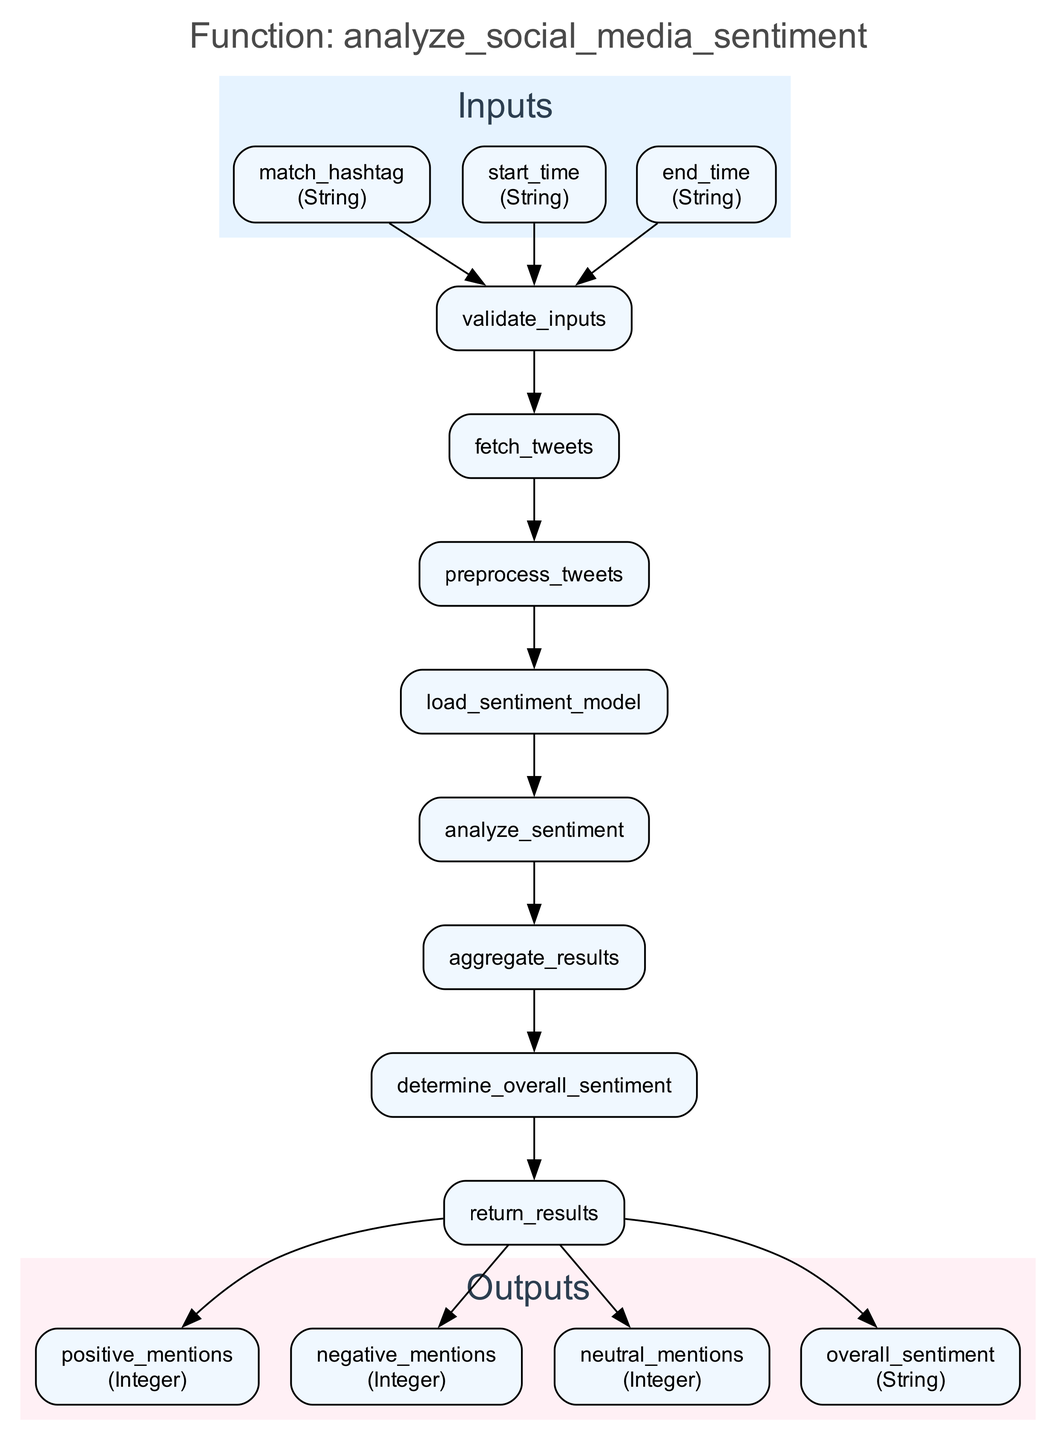What's the first step in the function? The function begins with the step labeled "validate_inputs." This step is the first node connected from the input nodes, indicating that input validation occurs before any other processing.
Answer: validate_inputs How many outputs does the function generate? The function produces four outputs. Looking at the output nodes in the diagram, I can count them: positive mentions, negative mentions, neutral mentions, and overall sentiment.
Answer: 4 Which node directly follows the "fetch_tweets" step? The "preprocess_tweets" step follows "fetch_tweets." This relationship shows that after fetching the tweets, they are preprocessed directly next in the sequence.
Answer: preprocess_tweets What type of data does the "start_time" input represent? The "start_time" input represents a String. This information comes from the input section where each input's type is specified.
Answer: String If the total number of steps is seven, what is the last process before returning results? The last process before returning results is "determine_overall_sentiment." Since it's the second to last step, it gets executed right before the output is returned.
Answer: determine_overall_sentiment After loading the sentiment model, what is the next action to be taken? The next action is "analyze_sentiment." This indicates that after loading the model, the function proceeds to analyze the sentiment of the fetched tweets.
Answer: analyze_sentiment Which output node represents the count of positive mentions? The output node representing the count of positive mentions is "positive_mentions." This is explicitly noted in the outputs section of the diagram.
Answer: positive_mentions What happens after the inputs are validated? After validation, the process involves "fetch_tweets," indicating that fetching tweets is the subsequent action taken after verifying the inputs.
Answer: fetch_tweets How are the results aggregated in the function? The results are aggregated in the "aggregate_results" step, which compiles sentiment scores to determine the counts of the different types of mentions.
Answer: aggregate_results 